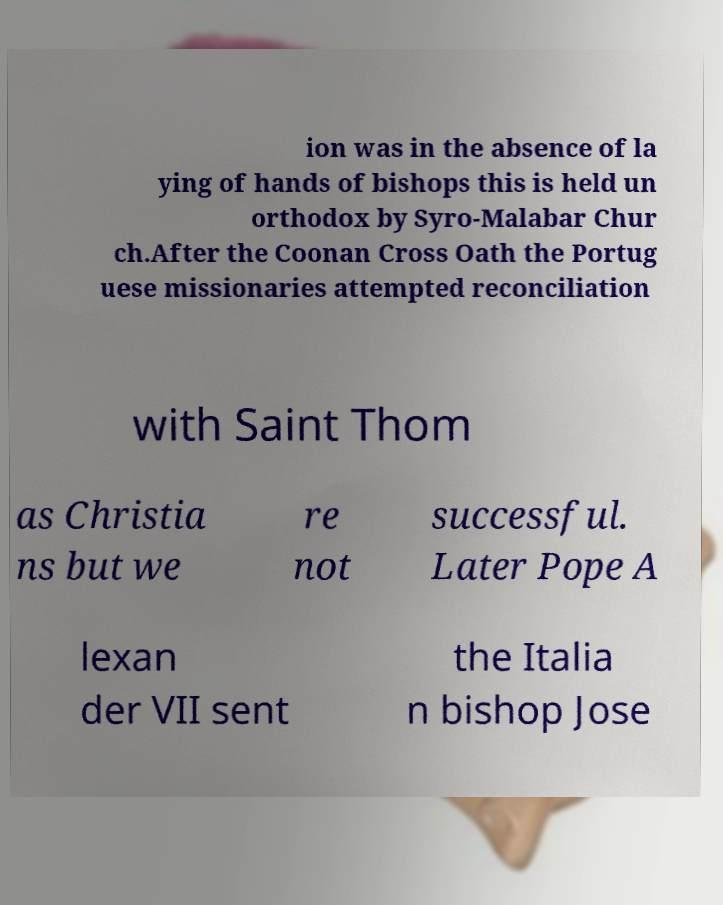Please read and relay the text visible in this image. What does it say? ion was in the absence of la ying of hands of bishops this is held un orthodox by Syro-Malabar Chur ch.After the Coonan Cross Oath the Portug uese missionaries attempted reconciliation with Saint Thom as Christia ns but we re not successful. Later Pope A lexan der VII sent the Italia n bishop Jose 